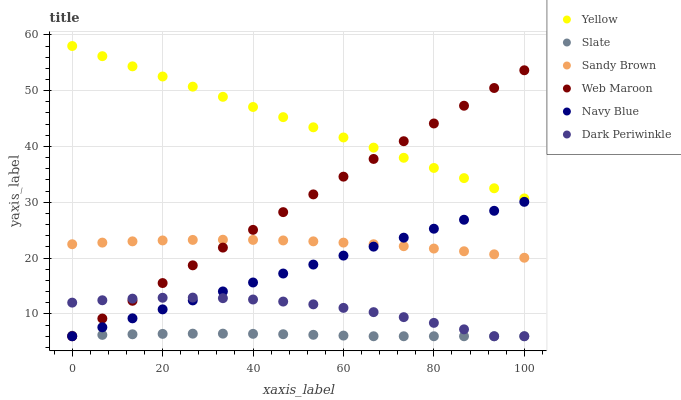Does Slate have the minimum area under the curve?
Answer yes or no. Yes. Does Yellow have the maximum area under the curve?
Answer yes or no. Yes. Does Web Maroon have the minimum area under the curve?
Answer yes or no. No. Does Web Maroon have the maximum area under the curve?
Answer yes or no. No. Is Navy Blue the smoothest?
Answer yes or no. Yes. Is Dark Periwinkle the roughest?
Answer yes or no. Yes. Is Slate the smoothest?
Answer yes or no. No. Is Slate the roughest?
Answer yes or no. No. Does Navy Blue have the lowest value?
Answer yes or no. Yes. Does Yellow have the lowest value?
Answer yes or no. No. Does Yellow have the highest value?
Answer yes or no. Yes. Does Web Maroon have the highest value?
Answer yes or no. No. Is Dark Periwinkle less than Yellow?
Answer yes or no. Yes. Is Yellow greater than Dark Periwinkle?
Answer yes or no. Yes. Does Slate intersect Web Maroon?
Answer yes or no. Yes. Is Slate less than Web Maroon?
Answer yes or no. No. Is Slate greater than Web Maroon?
Answer yes or no. No. Does Dark Periwinkle intersect Yellow?
Answer yes or no. No. 